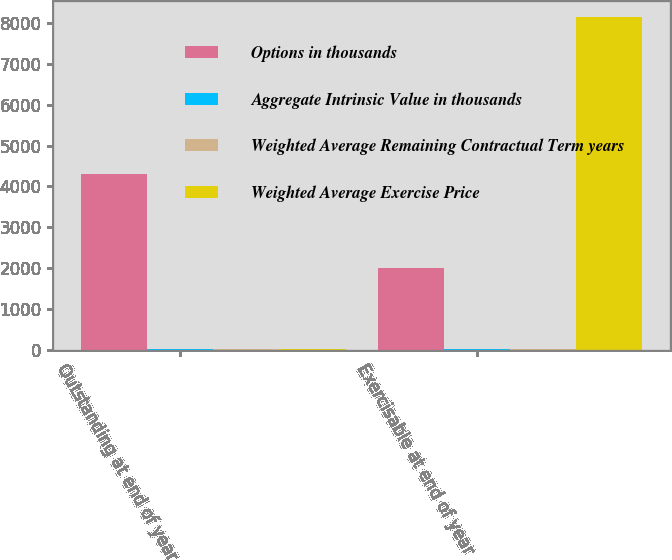<chart> <loc_0><loc_0><loc_500><loc_500><stacked_bar_chart><ecel><fcel>Outstanding at end of year<fcel>Exercisable at end of year<nl><fcel>Options in thousands<fcel>4306<fcel>1997<nl><fcel>Aggregate Intrinsic Value in thousands<fcel>11.04<fcel>10.72<nl><fcel>Weighted Average Remaining Contractual Term years<fcel>7.03<fcel>5.42<nl><fcel>Weighted Average Exercise Price<fcel>11.04<fcel>8151<nl></chart> 